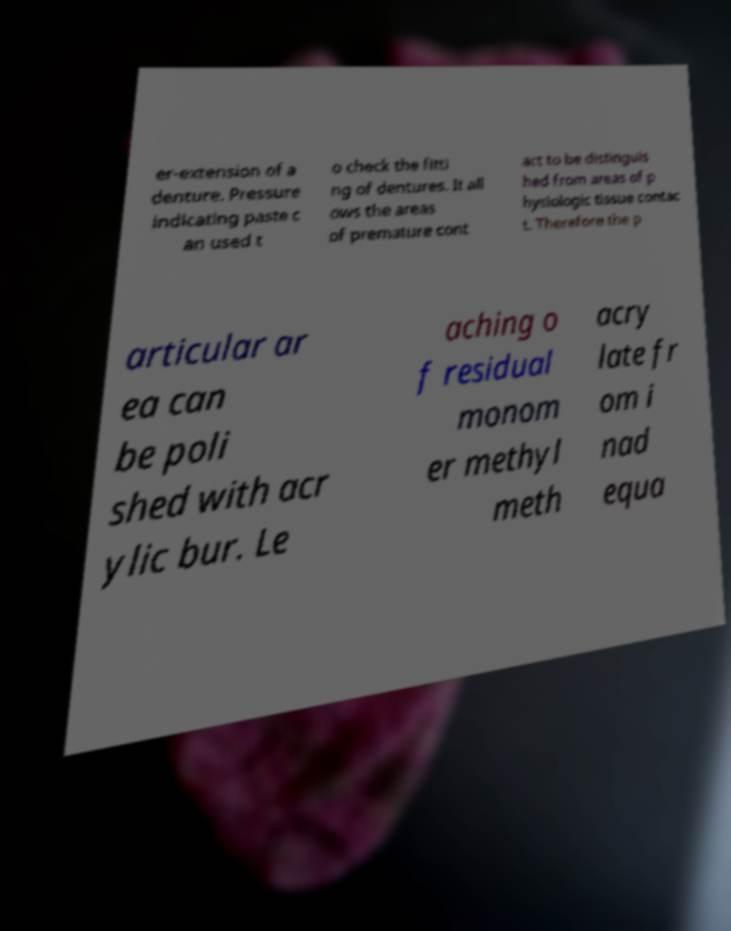Can you accurately transcribe the text from the provided image for me? er-extension of a denture. Pressure indicating paste c an used t o check the fitti ng of dentures. It all ows the areas of premature cont act to be distinguis hed from areas of p hysiologic tissue contac t. Therefore the p articular ar ea can be poli shed with acr ylic bur. Le aching o f residual monom er methyl meth acry late fr om i nad equa 